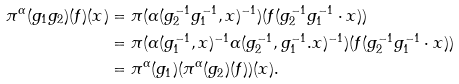Convert formula to latex. <formula><loc_0><loc_0><loc_500><loc_500>\pi ^ { \alpha } ( g _ { 1 } g _ { 2 } ) ( f ) ( x ) & = \pi ( \alpha ( g _ { 2 } ^ { - 1 } g _ { 1 } ^ { - 1 } , x ) ^ { - 1 } ) ( f ( g _ { 2 } ^ { - 1 } g _ { 1 } ^ { - 1 } \cdot x ) ) \\ & = \pi ( \alpha ( g _ { 1 } ^ { - 1 } , x ) ^ { - 1 } \alpha ( g _ { 2 } ^ { - 1 } , g _ { 1 } ^ { - 1 } . x ) ^ { - 1 } ) ( f ( g _ { 2 } ^ { - 1 } g _ { 1 } ^ { - 1 } \cdot x ) ) \\ & = \pi ^ { \alpha } ( g _ { 1 } ) ( \pi ^ { \alpha } ( g _ { 2 } ) ( f ) ) ( x ) .</formula> 